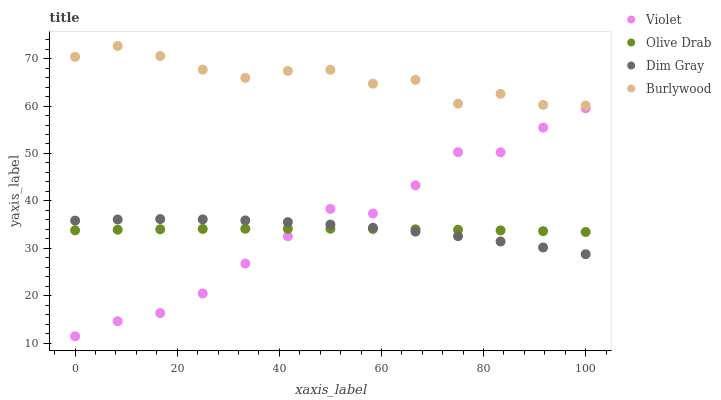Does Olive Drab have the minimum area under the curve?
Answer yes or no. Yes. Does Burlywood have the maximum area under the curve?
Answer yes or no. Yes. Does Dim Gray have the minimum area under the curve?
Answer yes or no. No. Does Dim Gray have the maximum area under the curve?
Answer yes or no. No. Is Olive Drab the smoothest?
Answer yes or no. Yes. Is Burlywood the roughest?
Answer yes or no. Yes. Is Dim Gray the smoothest?
Answer yes or no. No. Is Dim Gray the roughest?
Answer yes or no. No. Does Violet have the lowest value?
Answer yes or no. Yes. Does Dim Gray have the lowest value?
Answer yes or no. No. Does Burlywood have the highest value?
Answer yes or no. Yes. Does Dim Gray have the highest value?
Answer yes or no. No. Is Violet less than Burlywood?
Answer yes or no. Yes. Is Burlywood greater than Violet?
Answer yes or no. Yes. Does Olive Drab intersect Dim Gray?
Answer yes or no. Yes. Is Olive Drab less than Dim Gray?
Answer yes or no. No. Is Olive Drab greater than Dim Gray?
Answer yes or no. No. Does Violet intersect Burlywood?
Answer yes or no. No. 